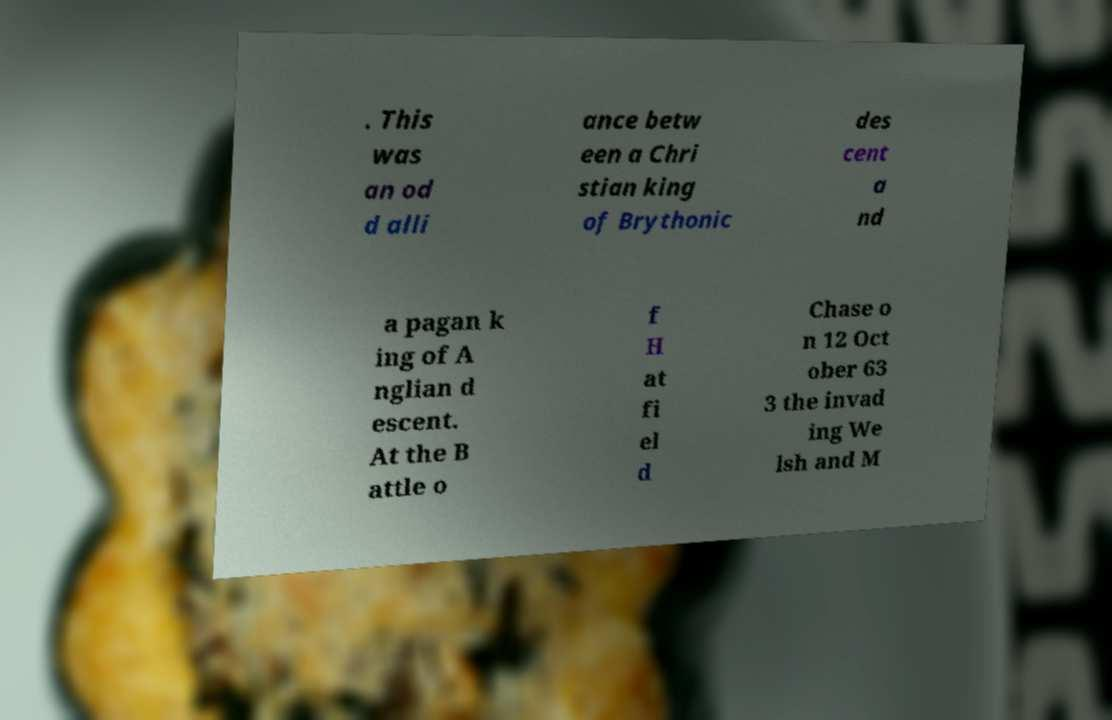Please identify and transcribe the text found in this image. . This was an od d alli ance betw een a Chri stian king of Brythonic des cent a nd a pagan k ing of A nglian d escent. At the B attle o f H at fi el d Chase o n 12 Oct ober 63 3 the invad ing We lsh and M 